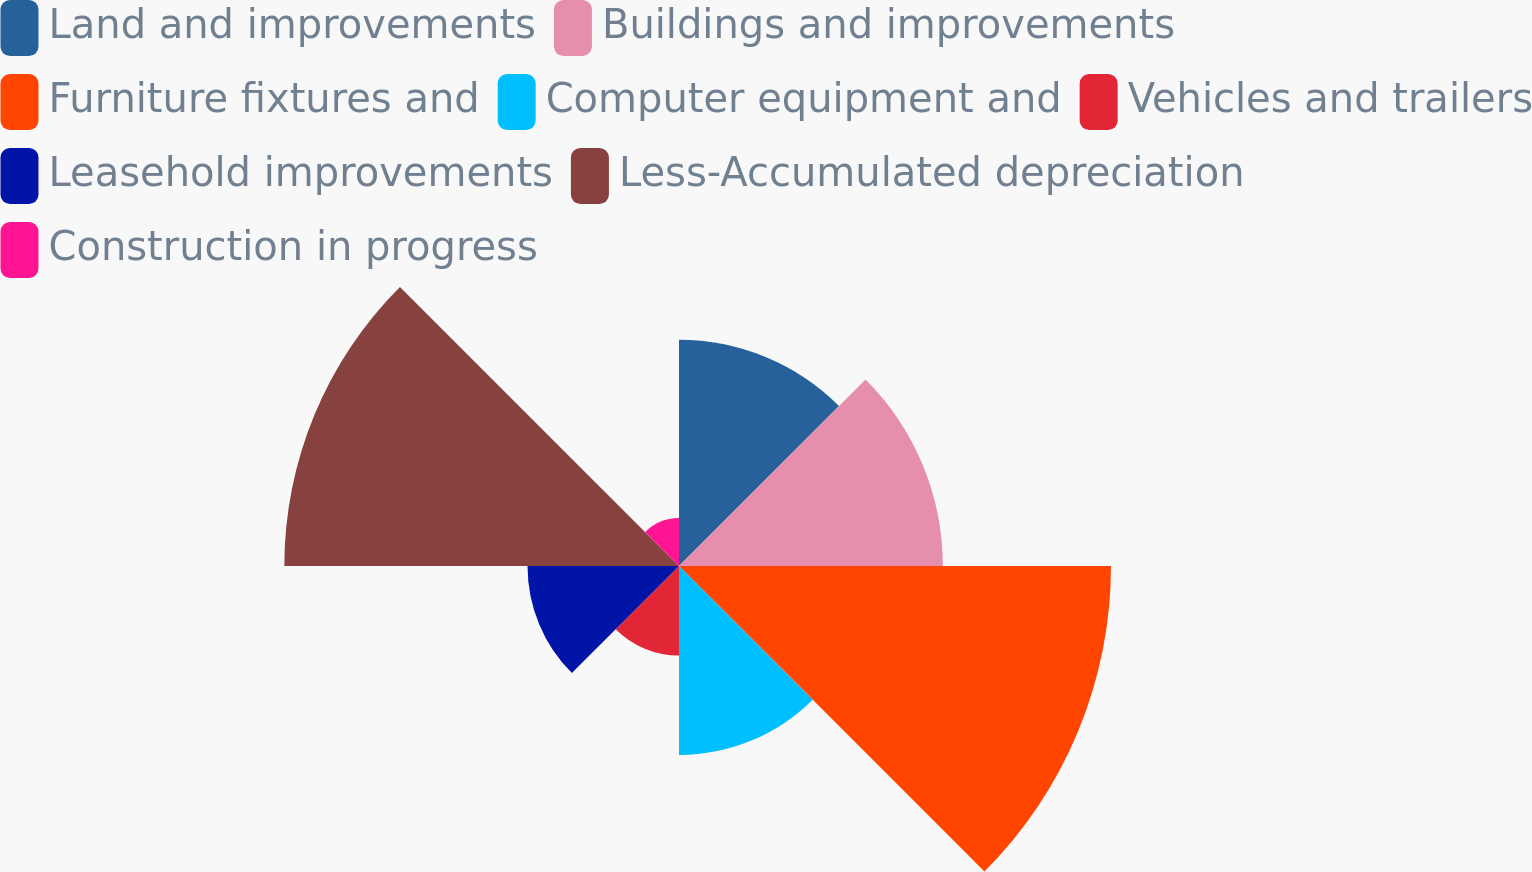Convert chart. <chart><loc_0><loc_0><loc_500><loc_500><pie_chart><fcel>Land and improvements<fcel>Buildings and improvements<fcel>Furniture fixtures and<fcel>Computer equipment and<fcel>Vehicles and trailers<fcel>Leasehold improvements<fcel>Less-Accumulated depreciation<fcel>Construction in progress<nl><fcel>12.61%<fcel>14.7%<fcel>24.07%<fcel>10.53%<fcel>4.99%<fcel>8.44%<fcel>21.99%<fcel>2.67%<nl></chart> 